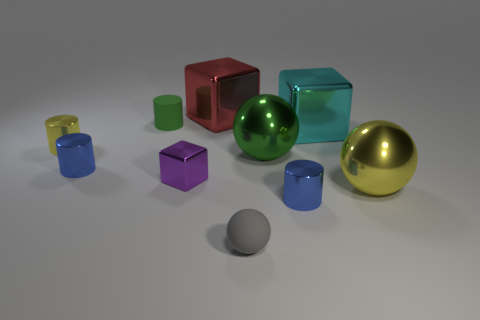Subtract all green cylinders. How many cylinders are left? 3 Subtract all gray balls. How many blue cylinders are left? 2 Subtract all red blocks. How many blocks are left? 2 Subtract all spheres. How many objects are left? 7 Subtract 2 balls. How many balls are left? 1 Subtract all cyan spheres. Subtract all red cylinders. How many spheres are left? 3 Subtract all small blue metal cylinders. Subtract all balls. How many objects are left? 5 Add 8 cyan objects. How many cyan objects are left? 9 Add 5 large green matte cylinders. How many large green matte cylinders exist? 5 Subtract 1 blue cylinders. How many objects are left? 9 